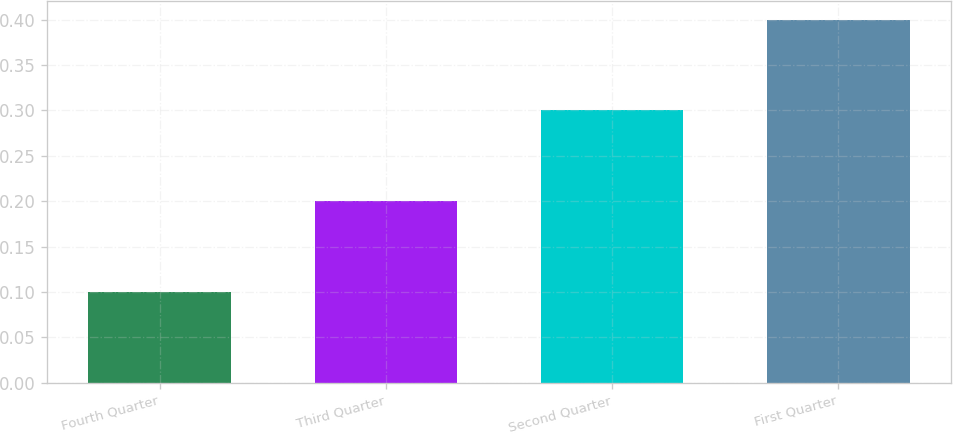<chart> <loc_0><loc_0><loc_500><loc_500><bar_chart><fcel>Fourth Quarter<fcel>Third Quarter<fcel>Second Quarter<fcel>First Quarter<nl><fcel>0.1<fcel>0.2<fcel>0.3<fcel>0.4<nl></chart> 